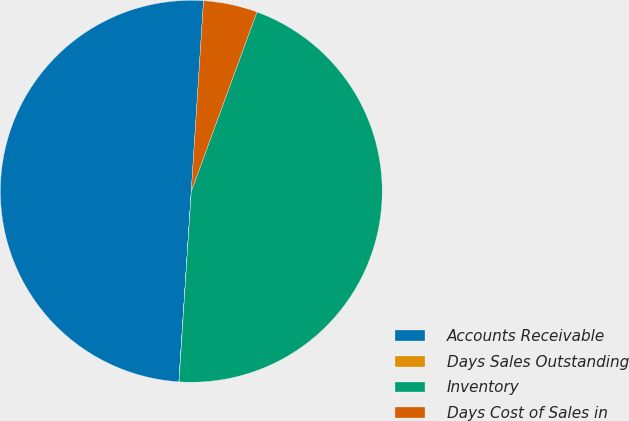Convert chart to OTSL. <chart><loc_0><loc_0><loc_500><loc_500><pie_chart><fcel>Accounts Receivable<fcel>Days Sales Outstanding<fcel>Inventory<fcel>Days Cost of Sales in<nl><fcel>49.99%<fcel>0.01%<fcel>45.44%<fcel>4.56%<nl></chart> 